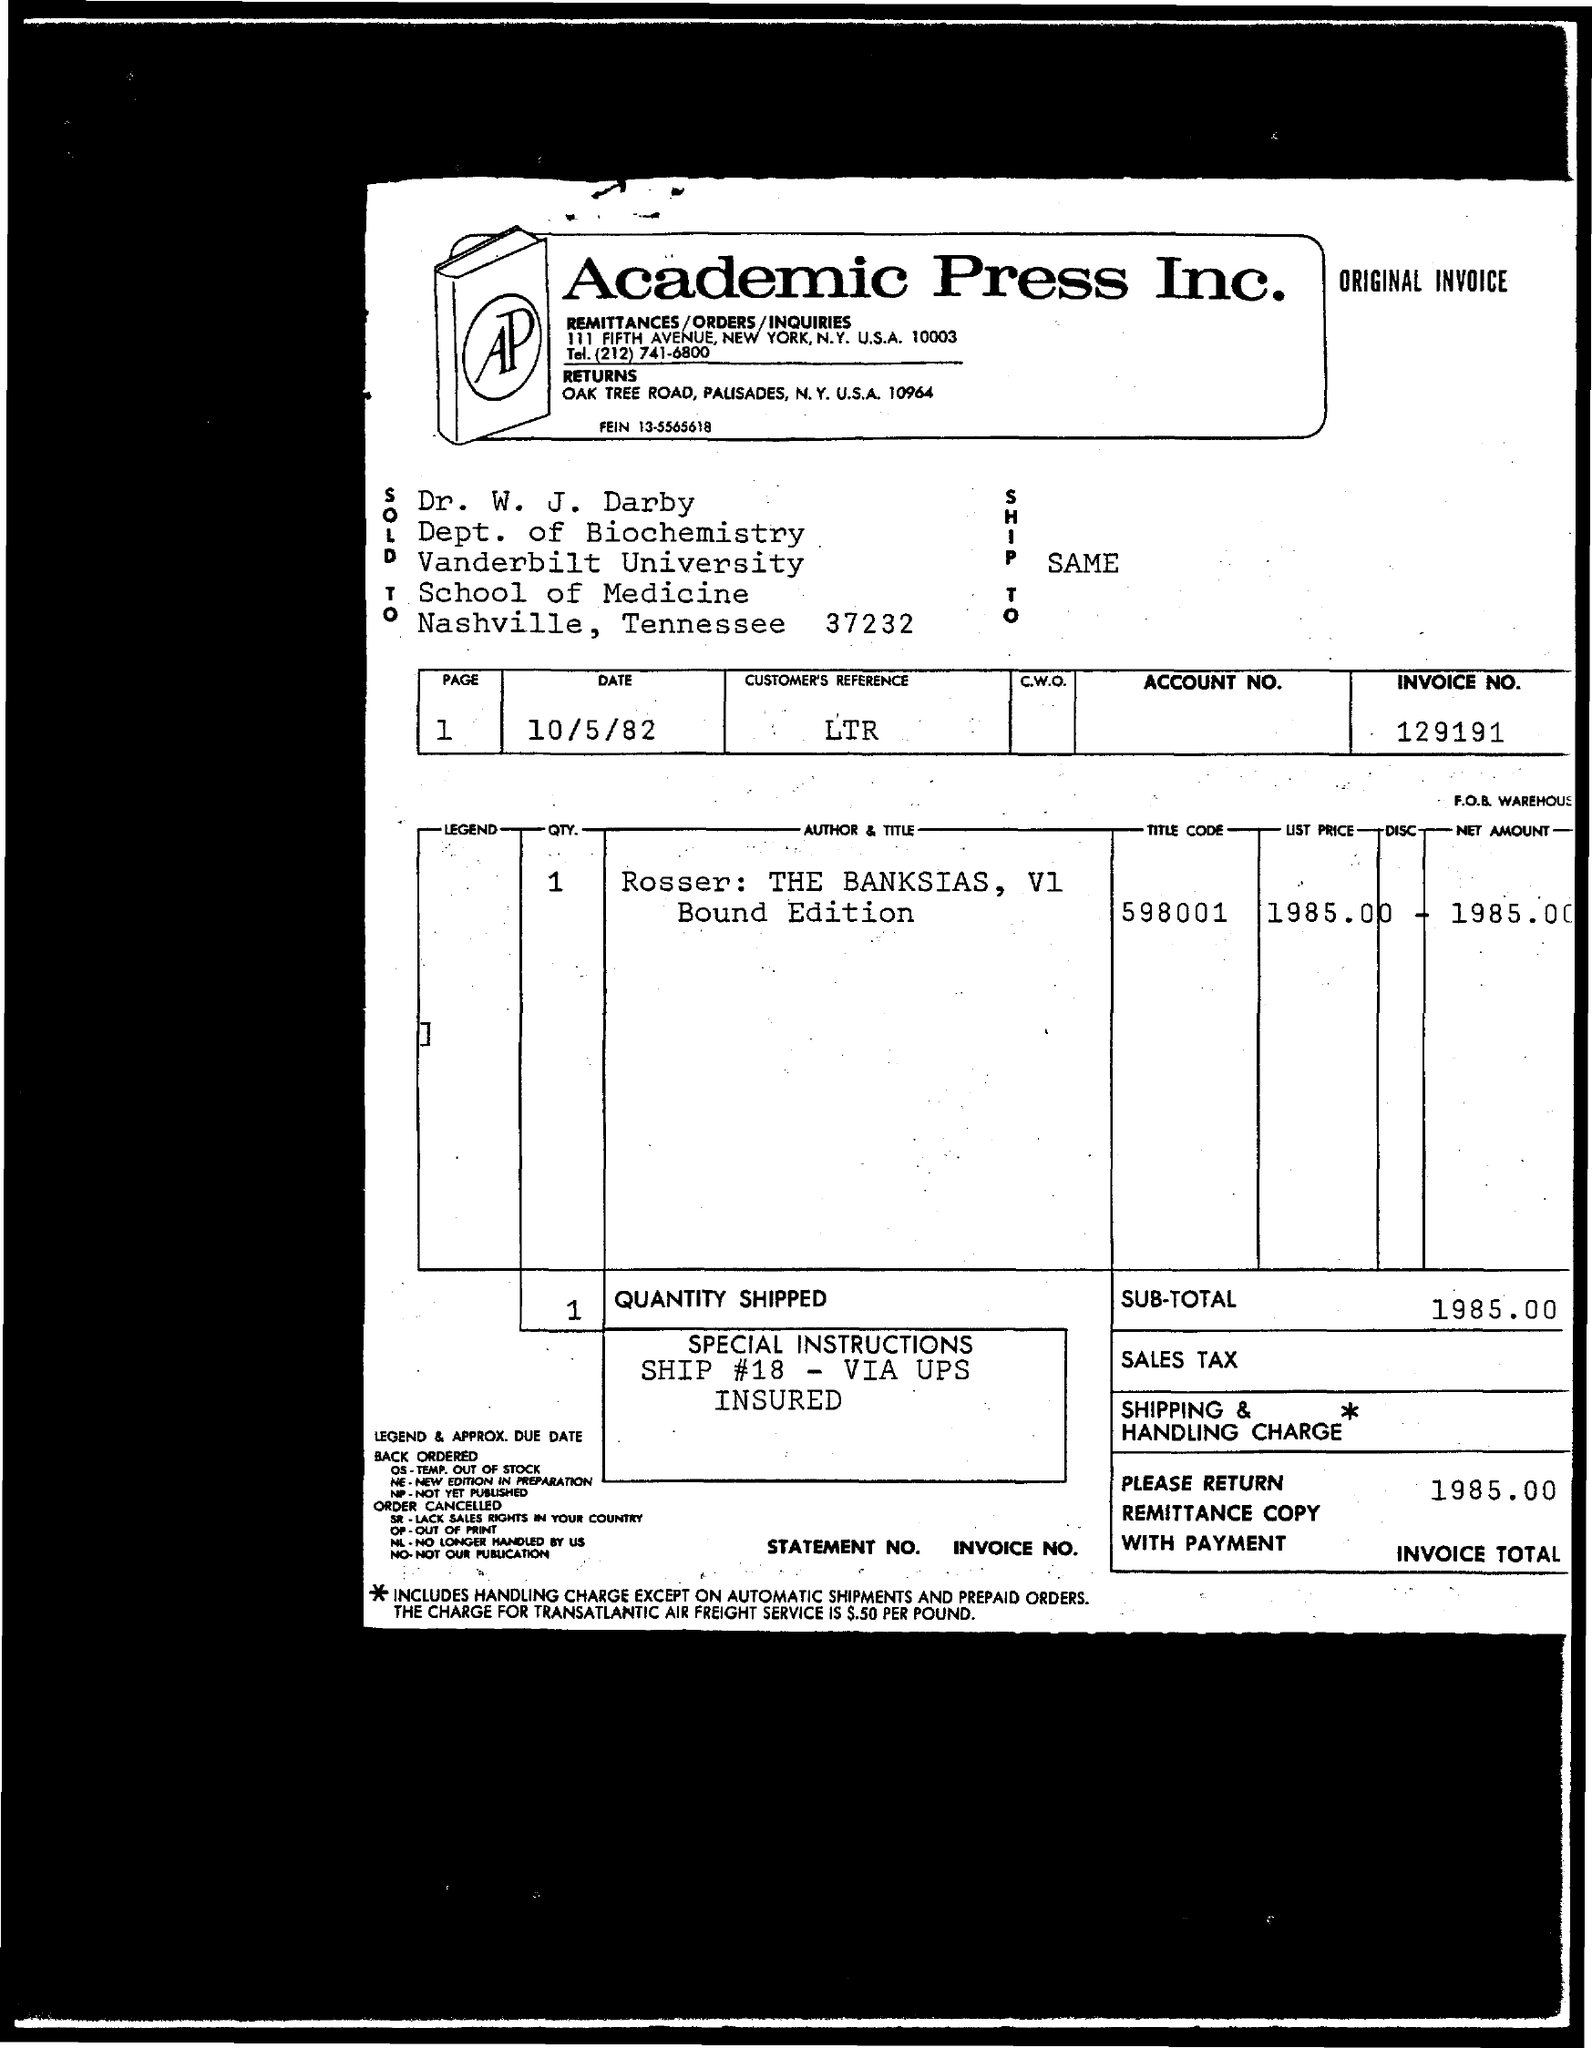Which company is raising the invoice?
Offer a very short reply. Academic Press Inc. What is the payee's name given in the invoice?
Your response must be concise. Dr. W. J. Darby. What is the invoice no. given in the document?
Your answer should be compact. 129191. What is the issued date of the invoice?
Your response must be concise. 10/5/82. What is the customer's reference id mentioned in the invoice?
Make the answer very short. LTR. What is the title code of the item mentioned in the invoice?
Provide a succinct answer. 598001. What is the net amount given in the invoice?
Make the answer very short. 1985. 